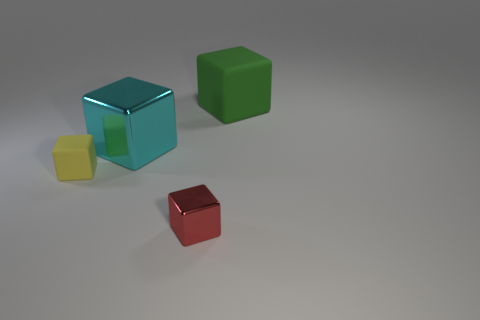What number of other objects are there of the same shape as the cyan object? Aside from the cyan cube, there are two other cubes of different colors present in the image, making for a total of three cubes, including the cyan one. 